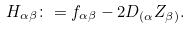Convert formula to latex. <formula><loc_0><loc_0><loc_500><loc_500>H _ { \alpha \beta } \colon = f _ { \alpha \beta } - 2 D _ { ( \alpha } Z _ { \beta ) } .</formula> 